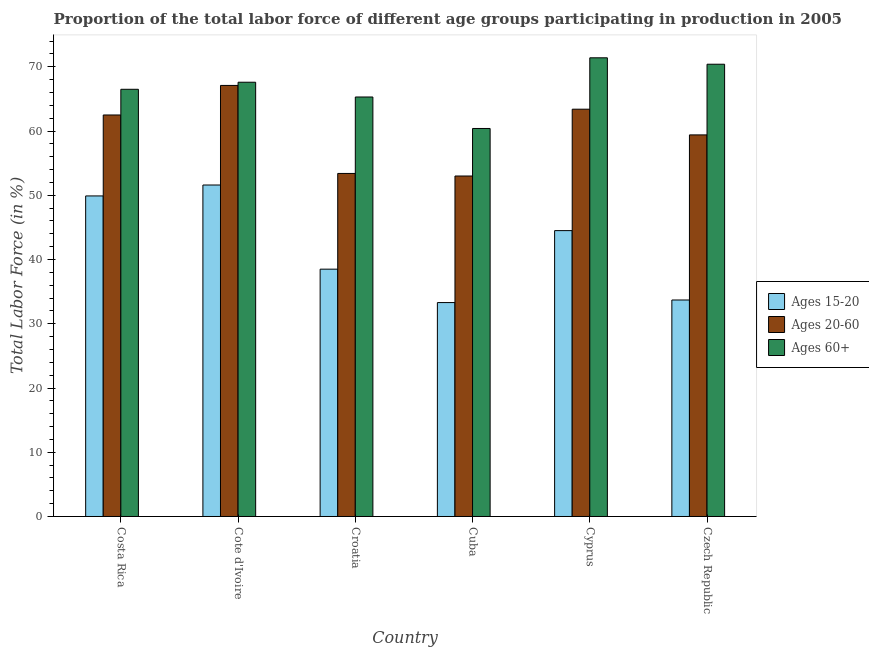How many different coloured bars are there?
Provide a succinct answer. 3. How many groups of bars are there?
Keep it short and to the point. 6. Are the number of bars on each tick of the X-axis equal?
Your answer should be very brief. Yes. How many bars are there on the 5th tick from the left?
Ensure brevity in your answer.  3. What is the label of the 4th group of bars from the left?
Provide a short and direct response. Cuba. In how many cases, is the number of bars for a given country not equal to the number of legend labels?
Provide a succinct answer. 0. What is the percentage of labor force within the age group 15-20 in Croatia?
Offer a terse response. 38.5. Across all countries, what is the maximum percentage of labor force within the age group 15-20?
Ensure brevity in your answer.  51.6. Across all countries, what is the minimum percentage of labor force within the age group 15-20?
Your answer should be very brief. 33.3. In which country was the percentage of labor force within the age group 20-60 maximum?
Ensure brevity in your answer.  Cote d'Ivoire. In which country was the percentage of labor force above age 60 minimum?
Offer a terse response. Cuba. What is the total percentage of labor force within the age group 15-20 in the graph?
Offer a terse response. 251.5. What is the difference between the percentage of labor force above age 60 in Cuba and that in Czech Republic?
Offer a terse response. -10. What is the difference between the percentage of labor force within the age group 20-60 in Costa Rica and the percentage of labor force within the age group 15-20 in Cote d'Ivoire?
Your answer should be very brief. 10.9. What is the average percentage of labor force within the age group 20-60 per country?
Provide a succinct answer. 59.8. What is the difference between the percentage of labor force within the age group 20-60 and percentage of labor force within the age group 15-20 in Costa Rica?
Your answer should be very brief. 12.6. In how many countries, is the percentage of labor force within the age group 20-60 greater than 62 %?
Your answer should be compact. 3. What is the ratio of the percentage of labor force within the age group 15-20 in Cyprus to that in Czech Republic?
Your answer should be compact. 1.32. Is the percentage of labor force above age 60 in Costa Rica less than that in Cote d'Ivoire?
Provide a succinct answer. Yes. Is the difference between the percentage of labor force above age 60 in Costa Rica and Cote d'Ivoire greater than the difference between the percentage of labor force within the age group 20-60 in Costa Rica and Cote d'Ivoire?
Offer a terse response. Yes. What is the difference between the highest and the second highest percentage of labor force within the age group 15-20?
Keep it short and to the point. 1.7. What is the difference between the highest and the lowest percentage of labor force above age 60?
Offer a terse response. 11. What does the 3rd bar from the left in Cote d'Ivoire represents?
Offer a terse response. Ages 60+. What does the 1st bar from the right in Croatia represents?
Offer a terse response. Ages 60+. Are all the bars in the graph horizontal?
Offer a very short reply. No. How many countries are there in the graph?
Offer a very short reply. 6. What is the difference between two consecutive major ticks on the Y-axis?
Offer a terse response. 10. Are the values on the major ticks of Y-axis written in scientific E-notation?
Ensure brevity in your answer.  No. Does the graph contain any zero values?
Keep it short and to the point. No. Where does the legend appear in the graph?
Your answer should be compact. Center right. How many legend labels are there?
Offer a very short reply. 3. What is the title of the graph?
Keep it short and to the point. Proportion of the total labor force of different age groups participating in production in 2005. Does "Resident buildings and public services" appear as one of the legend labels in the graph?
Keep it short and to the point. No. What is the Total Labor Force (in %) of Ages 15-20 in Costa Rica?
Offer a very short reply. 49.9. What is the Total Labor Force (in %) in Ages 20-60 in Costa Rica?
Provide a succinct answer. 62.5. What is the Total Labor Force (in %) in Ages 60+ in Costa Rica?
Your answer should be compact. 66.5. What is the Total Labor Force (in %) in Ages 15-20 in Cote d'Ivoire?
Offer a terse response. 51.6. What is the Total Labor Force (in %) in Ages 20-60 in Cote d'Ivoire?
Keep it short and to the point. 67.1. What is the Total Labor Force (in %) of Ages 60+ in Cote d'Ivoire?
Your answer should be very brief. 67.6. What is the Total Labor Force (in %) in Ages 15-20 in Croatia?
Ensure brevity in your answer.  38.5. What is the Total Labor Force (in %) of Ages 20-60 in Croatia?
Your answer should be compact. 53.4. What is the Total Labor Force (in %) in Ages 60+ in Croatia?
Your answer should be very brief. 65.3. What is the Total Labor Force (in %) in Ages 15-20 in Cuba?
Make the answer very short. 33.3. What is the Total Labor Force (in %) in Ages 60+ in Cuba?
Make the answer very short. 60.4. What is the Total Labor Force (in %) in Ages 15-20 in Cyprus?
Keep it short and to the point. 44.5. What is the Total Labor Force (in %) of Ages 20-60 in Cyprus?
Your answer should be compact. 63.4. What is the Total Labor Force (in %) in Ages 60+ in Cyprus?
Your answer should be very brief. 71.4. What is the Total Labor Force (in %) of Ages 15-20 in Czech Republic?
Give a very brief answer. 33.7. What is the Total Labor Force (in %) of Ages 20-60 in Czech Republic?
Your answer should be compact. 59.4. What is the Total Labor Force (in %) of Ages 60+ in Czech Republic?
Your response must be concise. 70.4. Across all countries, what is the maximum Total Labor Force (in %) in Ages 15-20?
Ensure brevity in your answer.  51.6. Across all countries, what is the maximum Total Labor Force (in %) of Ages 20-60?
Keep it short and to the point. 67.1. Across all countries, what is the maximum Total Labor Force (in %) of Ages 60+?
Your answer should be compact. 71.4. Across all countries, what is the minimum Total Labor Force (in %) of Ages 15-20?
Your answer should be very brief. 33.3. Across all countries, what is the minimum Total Labor Force (in %) in Ages 20-60?
Your response must be concise. 53. Across all countries, what is the minimum Total Labor Force (in %) in Ages 60+?
Your answer should be compact. 60.4. What is the total Total Labor Force (in %) of Ages 15-20 in the graph?
Your response must be concise. 251.5. What is the total Total Labor Force (in %) in Ages 20-60 in the graph?
Your response must be concise. 358.8. What is the total Total Labor Force (in %) of Ages 60+ in the graph?
Your answer should be compact. 401.6. What is the difference between the Total Labor Force (in %) in Ages 15-20 in Costa Rica and that in Cote d'Ivoire?
Your answer should be compact. -1.7. What is the difference between the Total Labor Force (in %) of Ages 20-60 in Costa Rica and that in Cote d'Ivoire?
Your response must be concise. -4.6. What is the difference between the Total Labor Force (in %) of Ages 20-60 in Costa Rica and that in Croatia?
Provide a succinct answer. 9.1. What is the difference between the Total Labor Force (in %) of Ages 60+ in Costa Rica and that in Cuba?
Your answer should be compact. 6.1. What is the difference between the Total Labor Force (in %) of Ages 20-60 in Costa Rica and that in Cyprus?
Provide a succinct answer. -0.9. What is the difference between the Total Labor Force (in %) in Ages 20-60 in Costa Rica and that in Czech Republic?
Give a very brief answer. 3.1. What is the difference between the Total Labor Force (in %) in Ages 20-60 in Cote d'Ivoire and that in Croatia?
Keep it short and to the point. 13.7. What is the difference between the Total Labor Force (in %) in Ages 60+ in Cote d'Ivoire and that in Croatia?
Provide a succinct answer. 2.3. What is the difference between the Total Labor Force (in %) of Ages 60+ in Cote d'Ivoire and that in Cuba?
Offer a very short reply. 7.2. What is the difference between the Total Labor Force (in %) in Ages 20-60 in Cote d'Ivoire and that in Cyprus?
Offer a terse response. 3.7. What is the difference between the Total Labor Force (in %) in Ages 60+ in Cote d'Ivoire and that in Czech Republic?
Offer a very short reply. -2.8. What is the difference between the Total Labor Force (in %) of Ages 15-20 in Croatia and that in Cuba?
Offer a terse response. 5.2. What is the difference between the Total Labor Force (in %) in Ages 20-60 in Croatia and that in Cyprus?
Ensure brevity in your answer.  -10. What is the difference between the Total Labor Force (in %) in Ages 60+ in Croatia and that in Cyprus?
Your answer should be compact. -6.1. What is the difference between the Total Labor Force (in %) in Ages 20-60 in Croatia and that in Czech Republic?
Offer a terse response. -6. What is the difference between the Total Labor Force (in %) of Ages 60+ in Cuba and that in Cyprus?
Provide a short and direct response. -11. What is the difference between the Total Labor Force (in %) of Ages 15-20 in Cyprus and that in Czech Republic?
Provide a succinct answer. 10.8. What is the difference between the Total Labor Force (in %) of Ages 60+ in Cyprus and that in Czech Republic?
Provide a succinct answer. 1. What is the difference between the Total Labor Force (in %) of Ages 15-20 in Costa Rica and the Total Labor Force (in %) of Ages 20-60 in Cote d'Ivoire?
Offer a terse response. -17.2. What is the difference between the Total Labor Force (in %) in Ages 15-20 in Costa Rica and the Total Labor Force (in %) in Ages 60+ in Cote d'Ivoire?
Keep it short and to the point. -17.7. What is the difference between the Total Labor Force (in %) of Ages 15-20 in Costa Rica and the Total Labor Force (in %) of Ages 60+ in Croatia?
Your response must be concise. -15.4. What is the difference between the Total Labor Force (in %) of Ages 20-60 in Costa Rica and the Total Labor Force (in %) of Ages 60+ in Croatia?
Your answer should be very brief. -2.8. What is the difference between the Total Labor Force (in %) in Ages 15-20 in Costa Rica and the Total Labor Force (in %) in Ages 20-60 in Cuba?
Offer a terse response. -3.1. What is the difference between the Total Labor Force (in %) of Ages 15-20 in Costa Rica and the Total Labor Force (in %) of Ages 60+ in Cuba?
Provide a short and direct response. -10.5. What is the difference between the Total Labor Force (in %) of Ages 20-60 in Costa Rica and the Total Labor Force (in %) of Ages 60+ in Cuba?
Keep it short and to the point. 2.1. What is the difference between the Total Labor Force (in %) of Ages 15-20 in Costa Rica and the Total Labor Force (in %) of Ages 20-60 in Cyprus?
Offer a terse response. -13.5. What is the difference between the Total Labor Force (in %) in Ages 15-20 in Costa Rica and the Total Labor Force (in %) in Ages 60+ in Cyprus?
Your response must be concise. -21.5. What is the difference between the Total Labor Force (in %) of Ages 15-20 in Costa Rica and the Total Labor Force (in %) of Ages 20-60 in Czech Republic?
Ensure brevity in your answer.  -9.5. What is the difference between the Total Labor Force (in %) in Ages 15-20 in Costa Rica and the Total Labor Force (in %) in Ages 60+ in Czech Republic?
Offer a terse response. -20.5. What is the difference between the Total Labor Force (in %) of Ages 15-20 in Cote d'Ivoire and the Total Labor Force (in %) of Ages 60+ in Croatia?
Ensure brevity in your answer.  -13.7. What is the difference between the Total Labor Force (in %) of Ages 20-60 in Cote d'Ivoire and the Total Labor Force (in %) of Ages 60+ in Croatia?
Provide a succinct answer. 1.8. What is the difference between the Total Labor Force (in %) of Ages 15-20 in Cote d'Ivoire and the Total Labor Force (in %) of Ages 20-60 in Cuba?
Provide a succinct answer. -1.4. What is the difference between the Total Labor Force (in %) in Ages 20-60 in Cote d'Ivoire and the Total Labor Force (in %) in Ages 60+ in Cuba?
Make the answer very short. 6.7. What is the difference between the Total Labor Force (in %) of Ages 15-20 in Cote d'Ivoire and the Total Labor Force (in %) of Ages 60+ in Cyprus?
Your answer should be compact. -19.8. What is the difference between the Total Labor Force (in %) in Ages 15-20 in Cote d'Ivoire and the Total Labor Force (in %) in Ages 60+ in Czech Republic?
Provide a short and direct response. -18.8. What is the difference between the Total Labor Force (in %) of Ages 15-20 in Croatia and the Total Labor Force (in %) of Ages 20-60 in Cuba?
Provide a short and direct response. -14.5. What is the difference between the Total Labor Force (in %) in Ages 15-20 in Croatia and the Total Labor Force (in %) in Ages 60+ in Cuba?
Offer a terse response. -21.9. What is the difference between the Total Labor Force (in %) in Ages 20-60 in Croatia and the Total Labor Force (in %) in Ages 60+ in Cuba?
Give a very brief answer. -7. What is the difference between the Total Labor Force (in %) of Ages 15-20 in Croatia and the Total Labor Force (in %) of Ages 20-60 in Cyprus?
Your response must be concise. -24.9. What is the difference between the Total Labor Force (in %) in Ages 15-20 in Croatia and the Total Labor Force (in %) in Ages 60+ in Cyprus?
Your answer should be compact. -32.9. What is the difference between the Total Labor Force (in %) in Ages 20-60 in Croatia and the Total Labor Force (in %) in Ages 60+ in Cyprus?
Offer a very short reply. -18. What is the difference between the Total Labor Force (in %) in Ages 15-20 in Croatia and the Total Labor Force (in %) in Ages 20-60 in Czech Republic?
Offer a terse response. -20.9. What is the difference between the Total Labor Force (in %) of Ages 15-20 in Croatia and the Total Labor Force (in %) of Ages 60+ in Czech Republic?
Make the answer very short. -31.9. What is the difference between the Total Labor Force (in %) of Ages 20-60 in Croatia and the Total Labor Force (in %) of Ages 60+ in Czech Republic?
Ensure brevity in your answer.  -17. What is the difference between the Total Labor Force (in %) in Ages 15-20 in Cuba and the Total Labor Force (in %) in Ages 20-60 in Cyprus?
Offer a terse response. -30.1. What is the difference between the Total Labor Force (in %) of Ages 15-20 in Cuba and the Total Labor Force (in %) of Ages 60+ in Cyprus?
Make the answer very short. -38.1. What is the difference between the Total Labor Force (in %) of Ages 20-60 in Cuba and the Total Labor Force (in %) of Ages 60+ in Cyprus?
Offer a terse response. -18.4. What is the difference between the Total Labor Force (in %) in Ages 15-20 in Cuba and the Total Labor Force (in %) in Ages 20-60 in Czech Republic?
Offer a terse response. -26.1. What is the difference between the Total Labor Force (in %) of Ages 15-20 in Cuba and the Total Labor Force (in %) of Ages 60+ in Czech Republic?
Provide a short and direct response. -37.1. What is the difference between the Total Labor Force (in %) of Ages 20-60 in Cuba and the Total Labor Force (in %) of Ages 60+ in Czech Republic?
Your response must be concise. -17.4. What is the difference between the Total Labor Force (in %) in Ages 15-20 in Cyprus and the Total Labor Force (in %) in Ages 20-60 in Czech Republic?
Your response must be concise. -14.9. What is the difference between the Total Labor Force (in %) in Ages 15-20 in Cyprus and the Total Labor Force (in %) in Ages 60+ in Czech Republic?
Offer a very short reply. -25.9. What is the average Total Labor Force (in %) of Ages 15-20 per country?
Your answer should be very brief. 41.92. What is the average Total Labor Force (in %) in Ages 20-60 per country?
Provide a succinct answer. 59.8. What is the average Total Labor Force (in %) of Ages 60+ per country?
Make the answer very short. 66.93. What is the difference between the Total Labor Force (in %) in Ages 15-20 and Total Labor Force (in %) in Ages 60+ in Costa Rica?
Give a very brief answer. -16.6. What is the difference between the Total Labor Force (in %) in Ages 15-20 and Total Labor Force (in %) in Ages 20-60 in Cote d'Ivoire?
Give a very brief answer. -15.5. What is the difference between the Total Labor Force (in %) in Ages 15-20 and Total Labor Force (in %) in Ages 60+ in Cote d'Ivoire?
Make the answer very short. -16. What is the difference between the Total Labor Force (in %) of Ages 20-60 and Total Labor Force (in %) of Ages 60+ in Cote d'Ivoire?
Your response must be concise. -0.5. What is the difference between the Total Labor Force (in %) in Ages 15-20 and Total Labor Force (in %) in Ages 20-60 in Croatia?
Provide a short and direct response. -14.9. What is the difference between the Total Labor Force (in %) in Ages 15-20 and Total Labor Force (in %) in Ages 60+ in Croatia?
Your answer should be compact. -26.8. What is the difference between the Total Labor Force (in %) of Ages 15-20 and Total Labor Force (in %) of Ages 20-60 in Cuba?
Give a very brief answer. -19.7. What is the difference between the Total Labor Force (in %) in Ages 15-20 and Total Labor Force (in %) in Ages 60+ in Cuba?
Give a very brief answer. -27.1. What is the difference between the Total Labor Force (in %) in Ages 15-20 and Total Labor Force (in %) in Ages 20-60 in Cyprus?
Your response must be concise. -18.9. What is the difference between the Total Labor Force (in %) in Ages 15-20 and Total Labor Force (in %) in Ages 60+ in Cyprus?
Keep it short and to the point. -26.9. What is the difference between the Total Labor Force (in %) in Ages 15-20 and Total Labor Force (in %) in Ages 20-60 in Czech Republic?
Keep it short and to the point. -25.7. What is the difference between the Total Labor Force (in %) of Ages 15-20 and Total Labor Force (in %) of Ages 60+ in Czech Republic?
Offer a terse response. -36.7. What is the ratio of the Total Labor Force (in %) of Ages 15-20 in Costa Rica to that in Cote d'Ivoire?
Offer a very short reply. 0.97. What is the ratio of the Total Labor Force (in %) in Ages 20-60 in Costa Rica to that in Cote d'Ivoire?
Your answer should be compact. 0.93. What is the ratio of the Total Labor Force (in %) of Ages 60+ in Costa Rica to that in Cote d'Ivoire?
Keep it short and to the point. 0.98. What is the ratio of the Total Labor Force (in %) of Ages 15-20 in Costa Rica to that in Croatia?
Offer a very short reply. 1.3. What is the ratio of the Total Labor Force (in %) in Ages 20-60 in Costa Rica to that in Croatia?
Your answer should be very brief. 1.17. What is the ratio of the Total Labor Force (in %) in Ages 60+ in Costa Rica to that in Croatia?
Give a very brief answer. 1.02. What is the ratio of the Total Labor Force (in %) in Ages 15-20 in Costa Rica to that in Cuba?
Your response must be concise. 1.5. What is the ratio of the Total Labor Force (in %) in Ages 20-60 in Costa Rica to that in Cuba?
Offer a terse response. 1.18. What is the ratio of the Total Labor Force (in %) in Ages 60+ in Costa Rica to that in Cuba?
Give a very brief answer. 1.1. What is the ratio of the Total Labor Force (in %) of Ages 15-20 in Costa Rica to that in Cyprus?
Make the answer very short. 1.12. What is the ratio of the Total Labor Force (in %) of Ages 20-60 in Costa Rica to that in Cyprus?
Provide a short and direct response. 0.99. What is the ratio of the Total Labor Force (in %) in Ages 60+ in Costa Rica to that in Cyprus?
Offer a very short reply. 0.93. What is the ratio of the Total Labor Force (in %) in Ages 15-20 in Costa Rica to that in Czech Republic?
Offer a terse response. 1.48. What is the ratio of the Total Labor Force (in %) in Ages 20-60 in Costa Rica to that in Czech Republic?
Your answer should be compact. 1.05. What is the ratio of the Total Labor Force (in %) of Ages 60+ in Costa Rica to that in Czech Republic?
Your answer should be compact. 0.94. What is the ratio of the Total Labor Force (in %) in Ages 15-20 in Cote d'Ivoire to that in Croatia?
Offer a very short reply. 1.34. What is the ratio of the Total Labor Force (in %) in Ages 20-60 in Cote d'Ivoire to that in Croatia?
Provide a succinct answer. 1.26. What is the ratio of the Total Labor Force (in %) of Ages 60+ in Cote d'Ivoire to that in Croatia?
Provide a succinct answer. 1.04. What is the ratio of the Total Labor Force (in %) in Ages 15-20 in Cote d'Ivoire to that in Cuba?
Your response must be concise. 1.55. What is the ratio of the Total Labor Force (in %) of Ages 20-60 in Cote d'Ivoire to that in Cuba?
Make the answer very short. 1.27. What is the ratio of the Total Labor Force (in %) in Ages 60+ in Cote d'Ivoire to that in Cuba?
Ensure brevity in your answer.  1.12. What is the ratio of the Total Labor Force (in %) in Ages 15-20 in Cote d'Ivoire to that in Cyprus?
Give a very brief answer. 1.16. What is the ratio of the Total Labor Force (in %) in Ages 20-60 in Cote d'Ivoire to that in Cyprus?
Make the answer very short. 1.06. What is the ratio of the Total Labor Force (in %) of Ages 60+ in Cote d'Ivoire to that in Cyprus?
Your answer should be compact. 0.95. What is the ratio of the Total Labor Force (in %) in Ages 15-20 in Cote d'Ivoire to that in Czech Republic?
Provide a succinct answer. 1.53. What is the ratio of the Total Labor Force (in %) in Ages 20-60 in Cote d'Ivoire to that in Czech Republic?
Give a very brief answer. 1.13. What is the ratio of the Total Labor Force (in %) of Ages 60+ in Cote d'Ivoire to that in Czech Republic?
Give a very brief answer. 0.96. What is the ratio of the Total Labor Force (in %) of Ages 15-20 in Croatia to that in Cuba?
Your response must be concise. 1.16. What is the ratio of the Total Labor Force (in %) of Ages 20-60 in Croatia to that in Cuba?
Provide a succinct answer. 1.01. What is the ratio of the Total Labor Force (in %) of Ages 60+ in Croatia to that in Cuba?
Provide a succinct answer. 1.08. What is the ratio of the Total Labor Force (in %) in Ages 15-20 in Croatia to that in Cyprus?
Give a very brief answer. 0.87. What is the ratio of the Total Labor Force (in %) in Ages 20-60 in Croatia to that in Cyprus?
Ensure brevity in your answer.  0.84. What is the ratio of the Total Labor Force (in %) of Ages 60+ in Croatia to that in Cyprus?
Keep it short and to the point. 0.91. What is the ratio of the Total Labor Force (in %) of Ages 15-20 in Croatia to that in Czech Republic?
Your answer should be compact. 1.14. What is the ratio of the Total Labor Force (in %) in Ages 20-60 in Croatia to that in Czech Republic?
Give a very brief answer. 0.9. What is the ratio of the Total Labor Force (in %) in Ages 60+ in Croatia to that in Czech Republic?
Provide a succinct answer. 0.93. What is the ratio of the Total Labor Force (in %) of Ages 15-20 in Cuba to that in Cyprus?
Keep it short and to the point. 0.75. What is the ratio of the Total Labor Force (in %) in Ages 20-60 in Cuba to that in Cyprus?
Give a very brief answer. 0.84. What is the ratio of the Total Labor Force (in %) of Ages 60+ in Cuba to that in Cyprus?
Give a very brief answer. 0.85. What is the ratio of the Total Labor Force (in %) in Ages 15-20 in Cuba to that in Czech Republic?
Offer a terse response. 0.99. What is the ratio of the Total Labor Force (in %) in Ages 20-60 in Cuba to that in Czech Republic?
Offer a terse response. 0.89. What is the ratio of the Total Labor Force (in %) of Ages 60+ in Cuba to that in Czech Republic?
Give a very brief answer. 0.86. What is the ratio of the Total Labor Force (in %) in Ages 15-20 in Cyprus to that in Czech Republic?
Ensure brevity in your answer.  1.32. What is the ratio of the Total Labor Force (in %) of Ages 20-60 in Cyprus to that in Czech Republic?
Offer a terse response. 1.07. What is the ratio of the Total Labor Force (in %) in Ages 60+ in Cyprus to that in Czech Republic?
Keep it short and to the point. 1.01. What is the difference between the highest and the second highest Total Labor Force (in %) of Ages 20-60?
Your answer should be compact. 3.7. What is the difference between the highest and the lowest Total Labor Force (in %) in Ages 15-20?
Make the answer very short. 18.3. What is the difference between the highest and the lowest Total Labor Force (in %) in Ages 60+?
Provide a succinct answer. 11. 